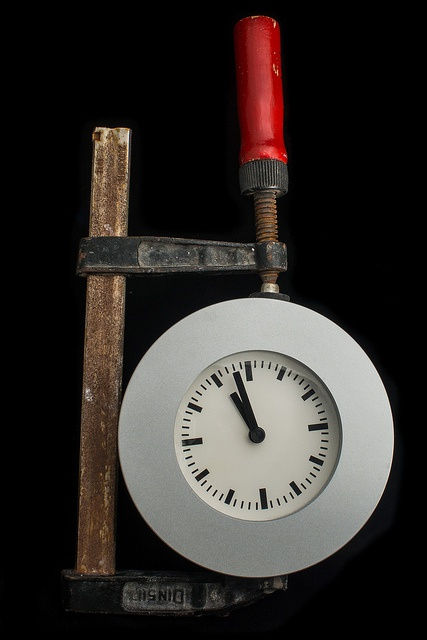Describe the objects in this image and their specific colors. I can see a clock in black, darkgray, lightgray, and gray tones in this image. 